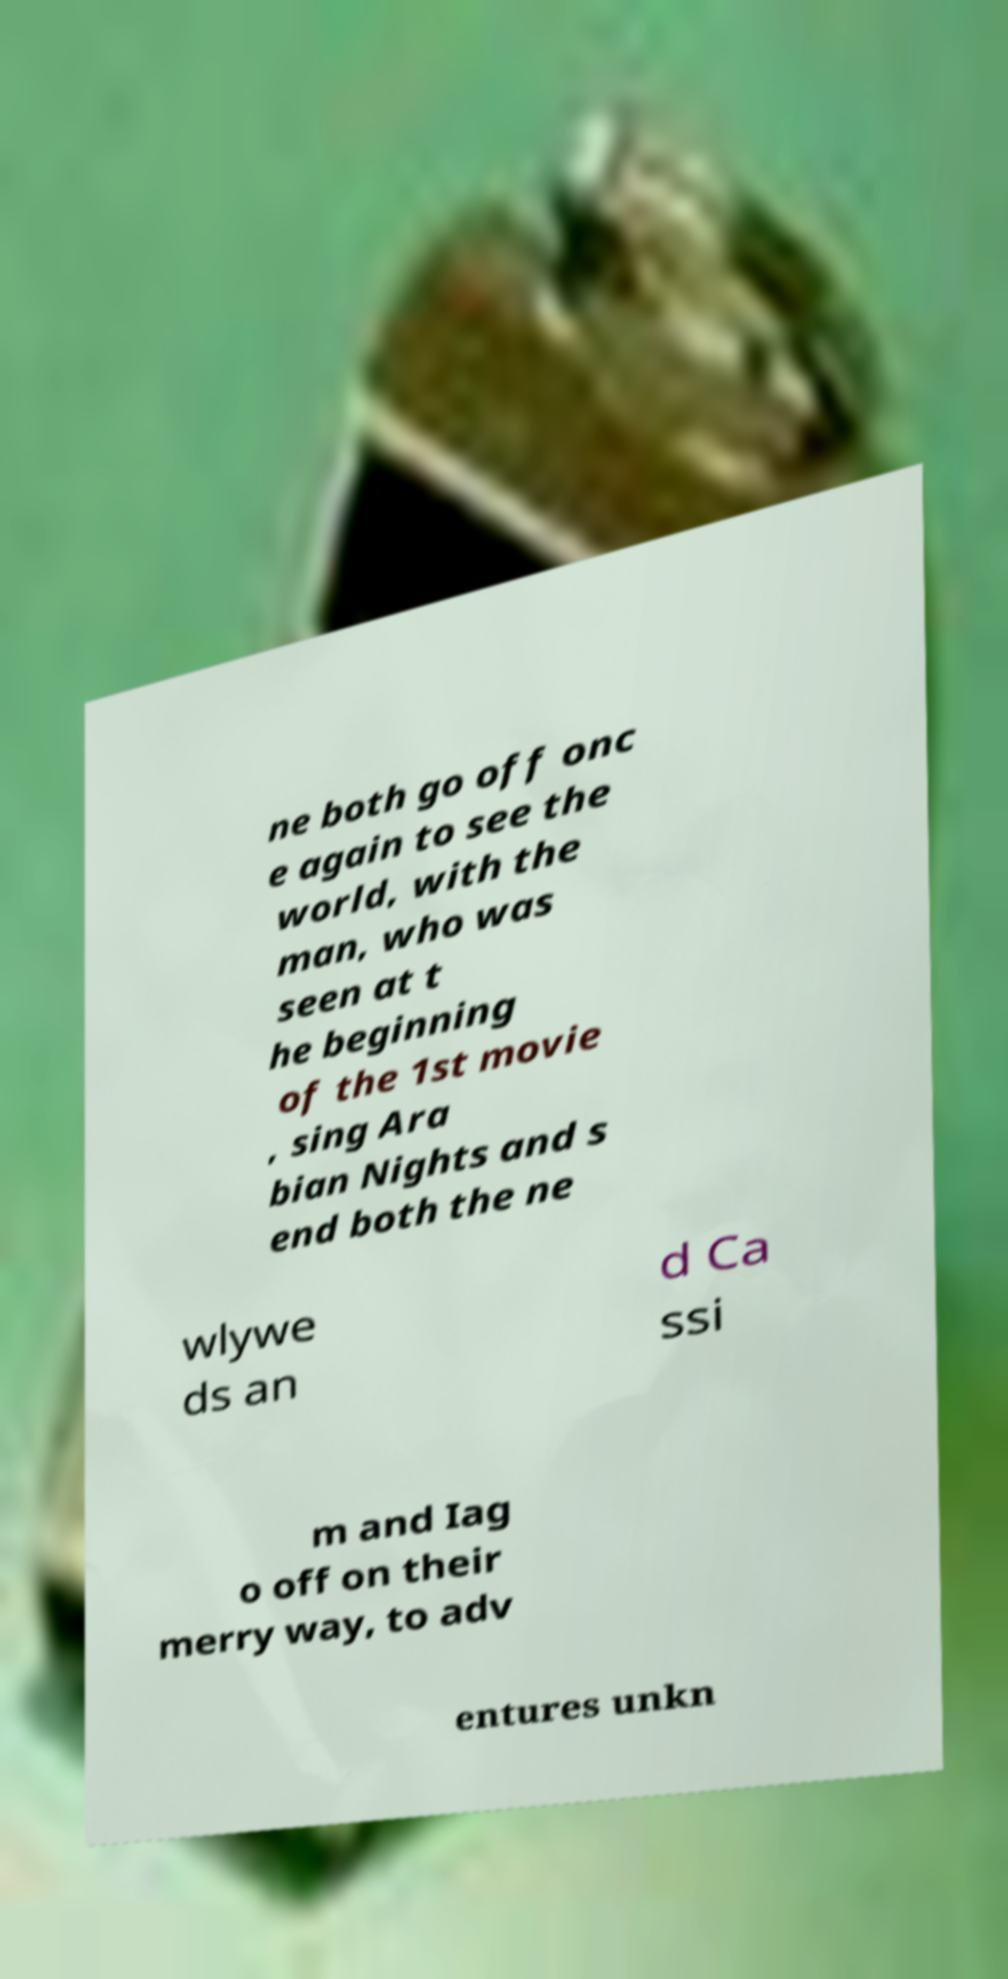Please identify and transcribe the text found in this image. ne both go off onc e again to see the world, with the man, who was seen at t he beginning of the 1st movie , sing Ara bian Nights and s end both the ne wlywe ds an d Ca ssi m and Iag o off on their merry way, to adv entures unkn 